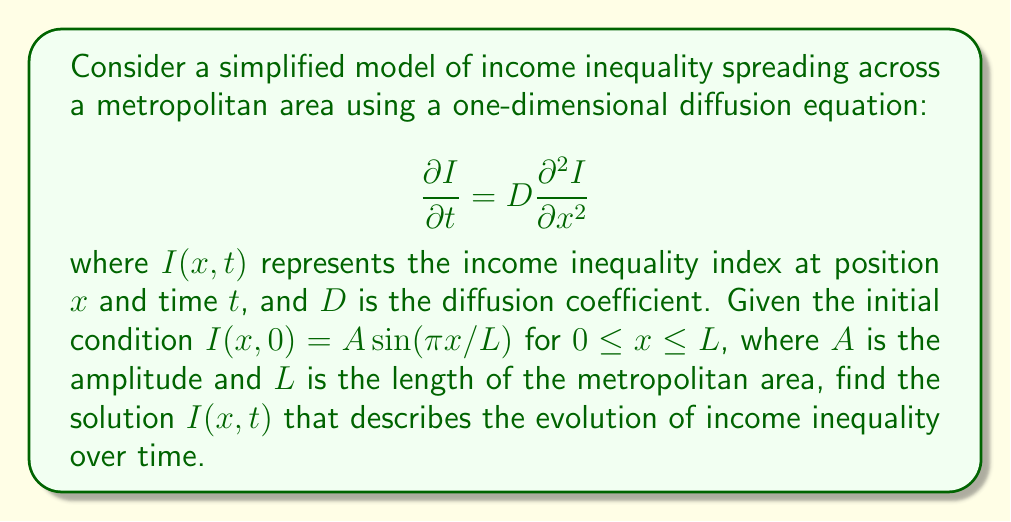Help me with this question. To solve this diffusion equation with the given initial condition, we follow these steps:

1) The general solution for the one-dimensional diffusion equation is of the form:
   $$I(x,t) = \sum_{n=1}^{\infty} c_n e^{-D(\frac{n\pi}{L})^2t} \sin(\frac{n\pi x}{L})$$

2) Our initial condition is:
   $$I(x,0) = A\sin(\frac{\pi x}{L})$$

3) Comparing the initial condition with the general solution at $t=0$, we see that only the $n=1$ term is non-zero, and $c_1 = A$.

4) Therefore, our solution simplifies to:
   $$I(x,t) = A e^{-D(\frac{\pi}{L})^2t} \sin(\frac{\pi x}{L})$$

5) This solution represents a standing wave with amplitude decaying exponentially over time. The rate of decay is determined by the diffusion coefficient $D$ and the size of the metropolitan area $L$.
Answer: $I(x,t) = A e^{-D(\frac{\pi}{L})^2t} \sin(\frac{\pi x}{L})$ 